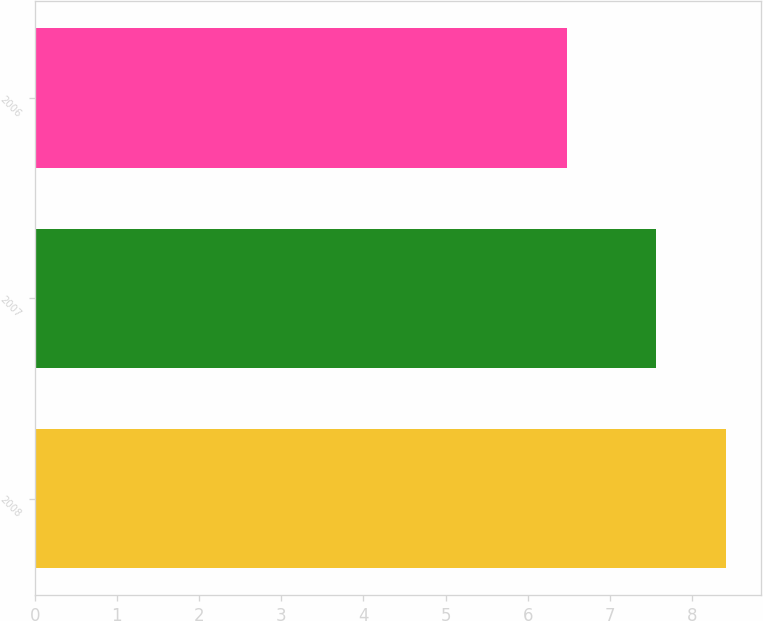Convert chart to OTSL. <chart><loc_0><loc_0><loc_500><loc_500><bar_chart><fcel>2008<fcel>2007<fcel>2006<nl><fcel>8.42<fcel>7.56<fcel>6.48<nl></chart> 